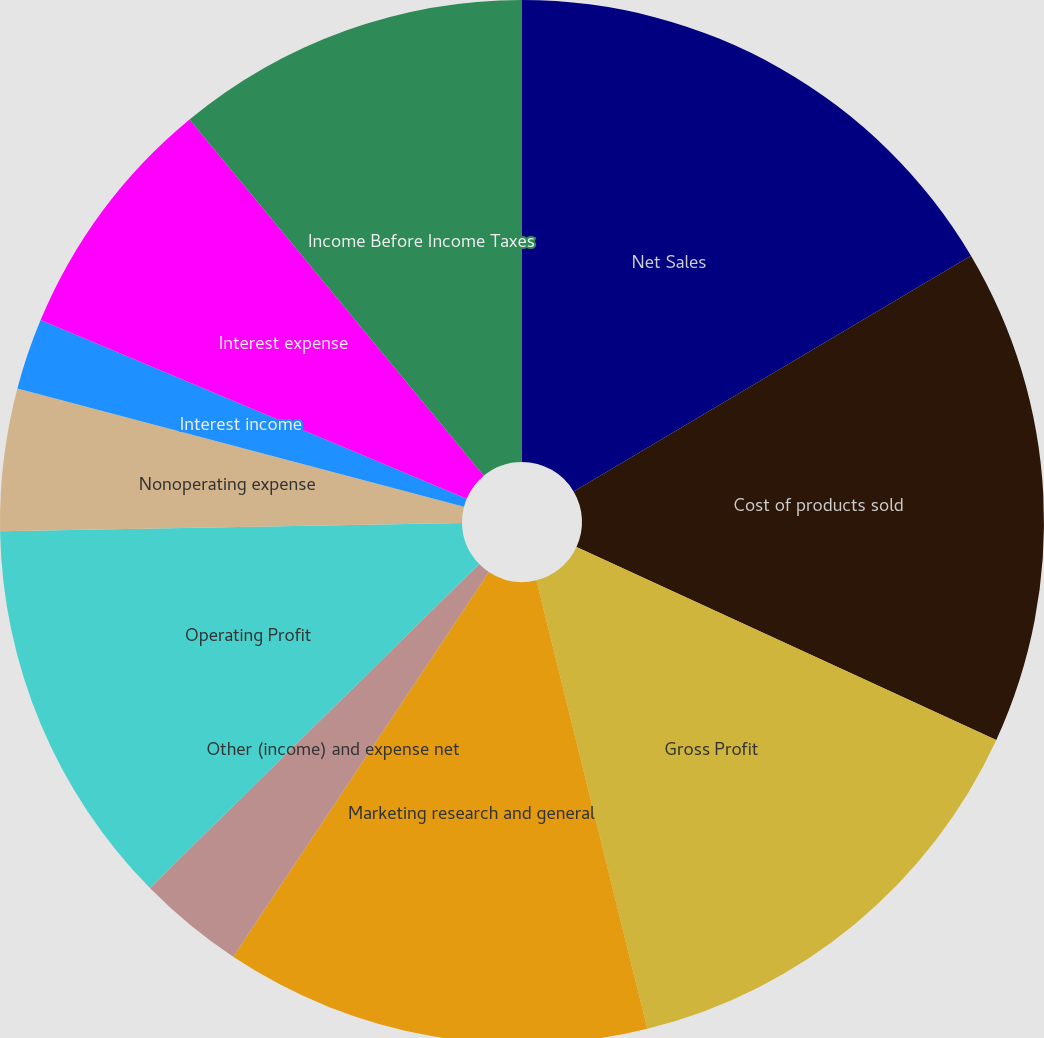<chart> <loc_0><loc_0><loc_500><loc_500><pie_chart><fcel>Net Sales<fcel>Cost of products sold<fcel>Gross Profit<fcel>Marketing research and general<fcel>Other (income) and expense net<fcel>Operating Profit<fcel>Nonoperating expense<fcel>Interest income<fcel>Interest expense<fcel>Income Before Income Taxes<nl><fcel>16.48%<fcel>15.38%<fcel>14.28%<fcel>13.19%<fcel>3.3%<fcel>12.09%<fcel>4.4%<fcel>2.2%<fcel>7.69%<fcel>10.99%<nl></chart> 